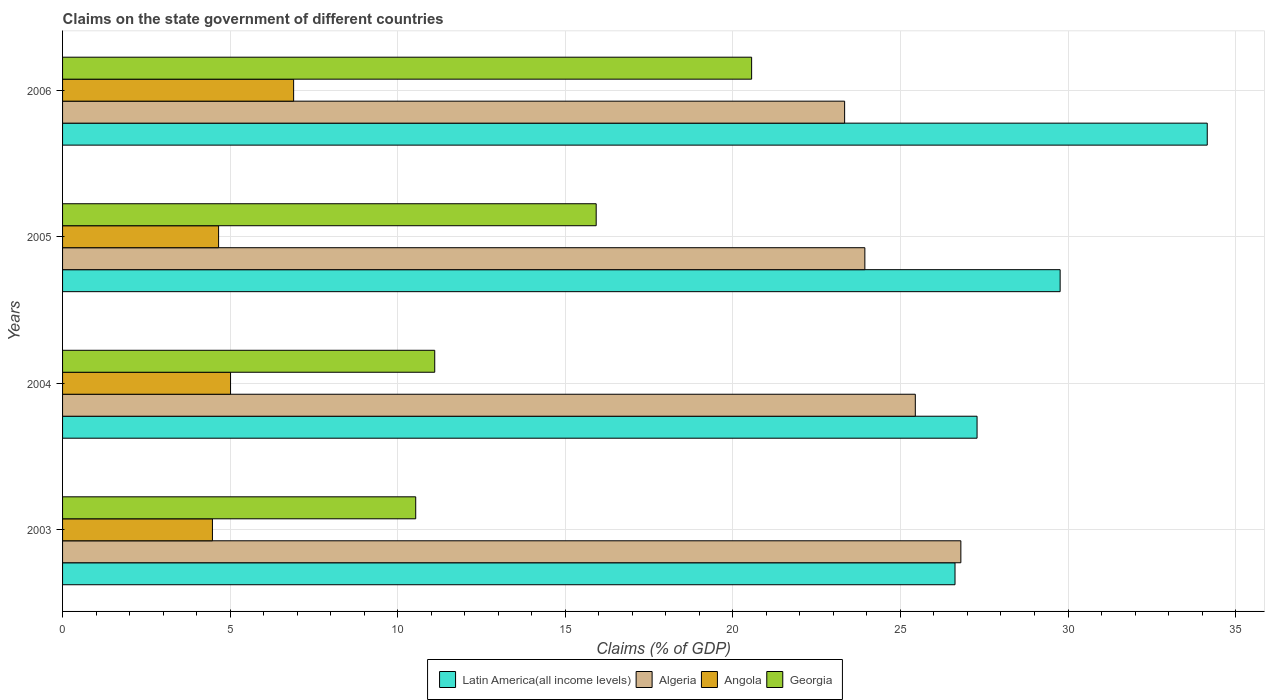In how many cases, is the number of bars for a given year not equal to the number of legend labels?
Offer a terse response. 0. What is the percentage of GDP claimed on the state government in Algeria in 2005?
Your answer should be compact. 23.94. Across all years, what is the maximum percentage of GDP claimed on the state government in Latin America(all income levels)?
Your response must be concise. 34.15. Across all years, what is the minimum percentage of GDP claimed on the state government in Georgia?
Offer a terse response. 10.54. In which year was the percentage of GDP claimed on the state government in Angola maximum?
Provide a short and direct response. 2006. What is the total percentage of GDP claimed on the state government in Latin America(all income levels) in the graph?
Ensure brevity in your answer.  117.83. What is the difference between the percentage of GDP claimed on the state government in Angola in 2003 and that in 2004?
Your answer should be very brief. -0.54. What is the difference between the percentage of GDP claimed on the state government in Latin America(all income levels) in 2004 and the percentage of GDP claimed on the state government in Georgia in 2003?
Provide a short and direct response. 16.75. What is the average percentage of GDP claimed on the state government in Angola per year?
Your answer should be very brief. 5.26. In the year 2005, what is the difference between the percentage of GDP claimed on the state government in Algeria and percentage of GDP claimed on the state government in Georgia?
Provide a short and direct response. 8.02. What is the ratio of the percentage of GDP claimed on the state government in Angola in 2004 to that in 2005?
Your answer should be very brief. 1.08. Is the difference between the percentage of GDP claimed on the state government in Algeria in 2003 and 2004 greater than the difference between the percentage of GDP claimed on the state government in Georgia in 2003 and 2004?
Keep it short and to the point. Yes. What is the difference between the highest and the second highest percentage of GDP claimed on the state government in Georgia?
Ensure brevity in your answer.  4.64. What is the difference between the highest and the lowest percentage of GDP claimed on the state government in Algeria?
Provide a succinct answer. 3.47. Is the sum of the percentage of GDP claimed on the state government in Georgia in 2003 and 2005 greater than the maximum percentage of GDP claimed on the state government in Angola across all years?
Keep it short and to the point. Yes. Is it the case that in every year, the sum of the percentage of GDP claimed on the state government in Latin America(all income levels) and percentage of GDP claimed on the state government in Georgia is greater than the sum of percentage of GDP claimed on the state government in Algeria and percentage of GDP claimed on the state government in Angola?
Your answer should be very brief. Yes. What does the 3rd bar from the top in 2004 represents?
Keep it short and to the point. Algeria. What does the 1st bar from the bottom in 2006 represents?
Offer a very short reply. Latin America(all income levels). Is it the case that in every year, the sum of the percentage of GDP claimed on the state government in Latin America(all income levels) and percentage of GDP claimed on the state government in Algeria is greater than the percentage of GDP claimed on the state government in Angola?
Your response must be concise. Yes. How many bars are there?
Offer a terse response. 16. Are all the bars in the graph horizontal?
Your answer should be compact. Yes. How many years are there in the graph?
Ensure brevity in your answer.  4. Are the values on the major ticks of X-axis written in scientific E-notation?
Provide a short and direct response. No. Does the graph contain any zero values?
Provide a short and direct response. No. Where does the legend appear in the graph?
Provide a succinct answer. Bottom center. How are the legend labels stacked?
Ensure brevity in your answer.  Horizontal. What is the title of the graph?
Provide a short and direct response. Claims on the state government of different countries. Does "Vanuatu" appear as one of the legend labels in the graph?
Your answer should be compact. No. What is the label or title of the X-axis?
Offer a terse response. Claims (% of GDP). What is the Claims (% of GDP) of Latin America(all income levels) in 2003?
Give a very brief answer. 26.63. What is the Claims (% of GDP) in Algeria in 2003?
Provide a short and direct response. 26.8. What is the Claims (% of GDP) in Angola in 2003?
Keep it short and to the point. 4.47. What is the Claims (% of GDP) in Georgia in 2003?
Keep it short and to the point. 10.54. What is the Claims (% of GDP) in Latin America(all income levels) in 2004?
Your answer should be compact. 27.29. What is the Claims (% of GDP) in Algeria in 2004?
Your answer should be very brief. 25.44. What is the Claims (% of GDP) of Angola in 2004?
Offer a terse response. 5.01. What is the Claims (% of GDP) in Georgia in 2004?
Make the answer very short. 11.1. What is the Claims (% of GDP) of Latin America(all income levels) in 2005?
Offer a terse response. 29.76. What is the Claims (% of GDP) of Algeria in 2005?
Keep it short and to the point. 23.94. What is the Claims (% of GDP) of Angola in 2005?
Keep it short and to the point. 4.66. What is the Claims (% of GDP) in Georgia in 2005?
Your answer should be compact. 15.92. What is the Claims (% of GDP) in Latin America(all income levels) in 2006?
Your response must be concise. 34.15. What is the Claims (% of GDP) of Algeria in 2006?
Your answer should be very brief. 23.33. What is the Claims (% of GDP) in Angola in 2006?
Provide a short and direct response. 6.89. What is the Claims (% of GDP) of Georgia in 2006?
Offer a very short reply. 20.56. Across all years, what is the maximum Claims (% of GDP) of Latin America(all income levels)?
Your response must be concise. 34.15. Across all years, what is the maximum Claims (% of GDP) of Algeria?
Make the answer very short. 26.8. Across all years, what is the maximum Claims (% of GDP) in Angola?
Make the answer very short. 6.89. Across all years, what is the maximum Claims (% of GDP) of Georgia?
Your answer should be very brief. 20.56. Across all years, what is the minimum Claims (% of GDP) in Latin America(all income levels)?
Provide a short and direct response. 26.63. Across all years, what is the minimum Claims (% of GDP) in Algeria?
Offer a terse response. 23.33. Across all years, what is the minimum Claims (% of GDP) in Angola?
Provide a succinct answer. 4.47. Across all years, what is the minimum Claims (% of GDP) in Georgia?
Ensure brevity in your answer.  10.54. What is the total Claims (% of GDP) of Latin America(all income levels) in the graph?
Offer a very short reply. 117.83. What is the total Claims (% of GDP) of Algeria in the graph?
Keep it short and to the point. 99.52. What is the total Claims (% of GDP) in Angola in the graph?
Your answer should be compact. 21.03. What is the total Claims (% of GDP) of Georgia in the graph?
Ensure brevity in your answer.  58.12. What is the difference between the Claims (% of GDP) in Latin America(all income levels) in 2003 and that in 2004?
Offer a very short reply. -0.66. What is the difference between the Claims (% of GDP) in Algeria in 2003 and that in 2004?
Keep it short and to the point. 1.36. What is the difference between the Claims (% of GDP) of Angola in 2003 and that in 2004?
Your answer should be compact. -0.54. What is the difference between the Claims (% of GDP) of Georgia in 2003 and that in 2004?
Make the answer very short. -0.57. What is the difference between the Claims (% of GDP) in Latin America(all income levels) in 2003 and that in 2005?
Give a very brief answer. -3.14. What is the difference between the Claims (% of GDP) in Algeria in 2003 and that in 2005?
Keep it short and to the point. 2.86. What is the difference between the Claims (% of GDP) in Angola in 2003 and that in 2005?
Make the answer very short. -0.18. What is the difference between the Claims (% of GDP) in Georgia in 2003 and that in 2005?
Ensure brevity in your answer.  -5.38. What is the difference between the Claims (% of GDP) of Latin America(all income levels) in 2003 and that in 2006?
Make the answer very short. -7.53. What is the difference between the Claims (% of GDP) in Algeria in 2003 and that in 2006?
Ensure brevity in your answer.  3.47. What is the difference between the Claims (% of GDP) of Angola in 2003 and that in 2006?
Your response must be concise. -2.42. What is the difference between the Claims (% of GDP) of Georgia in 2003 and that in 2006?
Provide a succinct answer. -10.02. What is the difference between the Claims (% of GDP) of Latin America(all income levels) in 2004 and that in 2005?
Your answer should be very brief. -2.48. What is the difference between the Claims (% of GDP) in Algeria in 2004 and that in 2005?
Give a very brief answer. 1.51. What is the difference between the Claims (% of GDP) of Angola in 2004 and that in 2005?
Offer a terse response. 0.36. What is the difference between the Claims (% of GDP) of Georgia in 2004 and that in 2005?
Your answer should be very brief. -4.82. What is the difference between the Claims (% of GDP) of Latin America(all income levels) in 2004 and that in 2006?
Offer a terse response. -6.87. What is the difference between the Claims (% of GDP) in Algeria in 2004 and that in 2006?
Keep it short and to the point. 2.11. What is the difference between the Claims (% of GDP) in Angola in 2004 and that in 2006?
Offer a terse response. -1.88. What is the difference between the Claims (% of GDP) in Georgia in 2004 and that in 2006?
Offer a very short reply. -9.46. What is the difference between the Claims (% of GDP) in Latin America(all income levels) in 2005 and that in 2006?
Ensure brevity in your answer.  -4.39. What is the difference between the Claims (% of GDP) in Algeria in 2005 and that in 2006?
Keep it short and to the point. 0.6. What is the difference between the Claims (% of GDP) of Angola in 2005 and that in 2006?
Offer a very short reply. -2.24. What is the difference between the Claims (% of GDP) in Georgia in 2005 and that in 2006?
Provide a short and direct response. -4.64. What is the difference between the Claims (% of GDP) of Latin America(all income levels) in 2003 and the Claims (% of GDP) of Algeria in 2004?
Offer a very short reply. 1.18. What is the difference between the Claims (% of GDP) in Latin America(all income levels) in 2003 and the Claims (% of GDP) in Angola in 2004?
Ensure brevity in your answer.  21.62. What is the difference between the Claims (% of GDP) of Latin America(all income levels) in 2003 and the Claims (% of GDP) of Georgia in 2004?
Offer a terse response. 15.52. What is the difference between the Claims (% of GDP) of Algeria in 2003 and the Claims (% of GDP) of Angola in 2004?
Provide a succinct answer. 21.79. What is the difference between the Claims (% of GDP) in Algeria in 2003 and the Claims (% of GDP) in Georgia in 2004?
Offer a very short reply. 15.7. What is the difference between the Claims (% of GDP) of Angola in 2003 and the Claims (% of GDP) of Georgia in 2004?
Give a very brief answer. -6.63. What is the difference between the Claims (% of GDP) of Latin America(all income levels) in 2003 and the Claims (% of GDP) of Algeria in 2005?
Your response must be concise. 2.69. What is the difference between the Claims (% of GDP) in Latin America(all income levels) in 2003 and the Claims (% of GDP) in Angola in 2005?
Give a very brief answer. 21.97. What is the difference between the Claims (% of GDP) of Latin America(all income levels) in 2003 and the Claims (% of GDP) of Georgia in 2005?
Provide a succinct answer. 10.71. What is the difference between the Claims (% of GDP) of Algeria in 2003 and the Claims (% of GDP) of Angola in 2005?
Your answer should be very brief. 22.15. What is the difference between the Claims (% of GDP) of Algeria in 2003 and the Claims (% of GDP) of Georgia in 2005?
Offer a terse response. 10.88. What is the difference between the Claims (% of GDP) in Angola in 2003 and the Claims (% of GDP) in Georgia in 2005?
Keep it short and to the point. -11.45. What is the difference between the Claims (% of GDP) of Latin America(all income levels) in 2003 and the Claims (% of GDP) of Algeria in 2006?
Your answer should be compact. 3.29. What is the difference between the Claims (% of GDP) in Latin America(all income levels) in 2003 and the Claims (% of GDP) in Angola in 2006?
Offer a terse response. 19.73. What is the difference between the Claims (% of GDP) in Latin America(all income levels) in 2003 and the Claims (% of GDP) in Georgia in 2006?
Offer a terse response. 6.07. What is the difference between the Claims (% of GDP) of Algeria in 2003 and the Claims (% of GDP) of Angola in 2006?
Your answer should be very brief. 19.91. What is the difference between the Claims (% of GDP) of Algeria in 2003 and the Claims (% of GDP) of Georgia in 2006?
Offer a terse response. 6.24. What is the difference between the Claims (% of GDP) of Angola in 2003 and the Claims (% of GDP) of Georgia in 2006?
Offer a very short reply. -16.09. What is the difference between the Claims (% of GDP) in Latin America(all income levels) in 2004 and the Claims (% of GDP) in Algeria in 2005?
Provide a succinct answer. 3.35. What is the difference between the Claims (% of GDP) in Latin America(all income levels) in 2004 and the Claims (% of GDP) in Angola in 2005?
Your answer should be compact. 22.63. What is the difference between the Claims (% of GDP) of Latin America(all income levels) in 2004 and the Claims (% of GDP) of Georgia in 2005?
Your answer should be compact. 11.36. What is the difference between the Claims (% of GDP) of Algeria in 2004 and the Claims (% of GDP) of Angola in 2005?
Provide a short and direct response. 20.79. What is the difference between the Claims (% of GDP) in Algeria in 2004 and the Claims (% of GDP) in Georgia in 2005?
Ensure brevity in your answer.  9.52. What is the difference between the Claims (% of GDP) in Angola in 2004 and the Claims (% of GDP) in Georgia in 2005?
Your response must be concise. -10.91. What is the difference between the Claims (% of GDP) of Latin America(all income levels) in 2004 and the Claims (% of GDP) of Algeria in 2006?
Offer a very short reply. 3.95. What is the difference between the Claims (% of GDP) of Latin America(all income levels) in 2004 and the Claims (% of GDP) of Angola in 2006?
Make the answer very short. 20.39. What is the difference between the Claims (% of GDP) of Latin America(all income levels) in 2004 and the Claims (% of GDP) of Georgia in 2006?
Ensure brevity in your answer.  6.73. What is the difference between the Claims (% of GDP) of Algeria in 2004 and the Claims (% of GDP) of Angola in 2006?
Give a very brief answer. 18.55. What is the difference between the Claims (% of GDP) of Algeria in 2004 and the Claims (% of GDP) of Georgia in 2006?
Offer a very short reply. 4.88. What is the difference between the Claims (% of GDP) in Angola in 2004 and the Claims (% of GDP) in Georgia in 2006?
Make the answer very short. -15.55. What is the difference between the Claims (% of GDP) in Latin America(all income levels) in 2005 and the Claims (% of GDP) in Algeria in 2006?
Your answer should be very brief. 6.43. What is the difference between the Claims (% of GDP) in Latin America(all income levels) in 2005 and the Claims (% of GDP) in Angola in 2006?
Offer a very short reply. 22.87. What is the difference between the Claims (% of GDP) in Latin America(all income levels) in 2005 and the Claims (% of GDP) in Georgia in 2006?
Offer a terse response. 9.21. What is the difference between the Claims (% of GDP) in Algeria in 2005 and the Claims (% of GDP) in Angola in 2006?
Ensure brevity in your answer.  17.04. What is the difference between the Claims (% of GDP) in Algeria in 2005 and the Claims (% of GDP) in Georgia in 2006?
Your answer should be very brief. 3.38. What is the difference between the Claims (% of GDP) of Angola in 2005 and the Claims (% of GDP) of Georgia in 2006?
Ensure brevity in your answer.  -15.9. What is the average Claims (% of GDP) in Latin America(all income levels) per year?
Your answer should be very brief. 29.46. What is the average Claims (% of GDP) in Algeria per year?
Your response must be concise. 24.88. What is the average Claims (% of GDP) of Angola per year?
Keep it short and to the point. 5.26. What is the average Claims (% of GDP) of Georgia per year?
Ensure brevity in your answer.  14.53. In the year 2003, what is the difference between the Claims (% of GDP) of Latin America(all income levels) and Claims (% of GDP) of Algeria?
Give a very brief answer. -0.17. In the year 2003, what is the difference between the Claims (% of GDP) of Latin America(all income levels) and Claims (% of GDP) of Angola?
Provide a short and direct response. 22.16. In the year 2003, what is the difference between the Claims (% of GDP) in Latin America(all income levels) and Claims (% of GDP) in Georgia?
Make the answer very short. 16.09. In the year 2003, what is the difference between the Claims (% of GDP) of Algeria and Claims (% of GDP) of Angola?
Keep it short and to the point. 22.33. In the year 2003, what is the difference between the Claims (% of GDP) in Algeria and Claims (% of GDP) in Georgia?
Ensure brevity in your answer.  16.27. In the year 2003, what is the difference between the Claims (% of GDP) in Angola and Claims (% of GDP) in Georgia?
Ensure brevity in your answer.  -6.07. In the year 2004, what is the difference between the Claims (% of GDP) in Latin America(all income levels) and Claims (% of GDP) in Algeria?
Your answer should be compact. 1.84. In the year 2004, what is the difference between the Claims (% of GDP) of Latin America(all income levels) and Claims (% of GDP) of Angola?
Ensure brevity in your answer.  22.27. In the year 2004, what is the difference between the Claims (% of GDP) in Latin America(all income levels) and Claims (% of GDP) in Georgia?
Offer a terse response. 16.18. In the year 2004, what is the difference between the Claims (% of GDP) in Algeria and Claims (% of GDP) in Angola?
Offer a terse response. 20.43. In the year 2004, what is the difference between the Claims (% of GDP) of Algeria and Claims (% of GDP) of Georgia?
Provide a succinct answer. 14.34. In the year 2004, what is the difference between the Claims (% of GDP) of Angola and Claims (% of GDP) of Georgia?
Your answer should be very brief. -6.09. In the year 2005, what is the difference between the Claims (% of GDP) of Latin America(all income levels) and Claims (% of GDP) of Algeria?
Your answer should be very brief. 5.83. In the year 2005, what is the difference between the Claims (% of GDP) in Latin America(all income levels) and Claims (% of GDP) in Angola?
Keep it short and to the point. 25.11. In the year 2005, what is the difference between the Claims (% of GDP) of Latin America(all income levels) and Claims (% of GDP) of Georgia?
Give a very brief answer. 13.84. In the year 2005, what is the difference between the Claims (% of GDP) of Algeria and Claims (% of GDP) of Angola?
Provide a short and direct response. 19.28. In the year 2005, what is the difference between the Claims (% of GDP) in Algeria and Claims (% of GDP) in Georgia?
Provide a short and direct response. 8.02. In the year 2005, what is the difference between the Claims (% of GDP) of Angola and Claims (% of GDP) of Georgia?
Your answer should be compact. -11.27. In the year 2006, what is the difference between the Claims (% of GDP) in Latin America(all income levels) and Claims (% of GDP) in Algeria?
Keep it short and to the point. 10.82. In the year 2006, what is the difference between the Claims (% of GDP) in Latin America(all income levels) and Claims (% of GDP) in Angola?
Offer a terse response. 27.26. In the year 2006, what is the difference between the Claims (% of GDP) in Latin America(all income levels) and Claims (% of GDP) in Georgia?
Offer a very short reply. 13.6. In the year 2006, what is the difference between the Claims (% of GDP) in Algeria and Claims (% of GDP) in Angola?
Your answer should be compact. 16.44. In the year 2006, what is the difference between the Claims (% of GDP) in Algeria and Claims (% of GDP) in Georgia?
Provide a short and direct response. 2.77. In the year 2006, what is the difference between the Claims (% of GDP) in Angola and Claims (% of GDP) in Georgia?
Your answer should be compact. -13.67. What is the ratio of the Claims (% of GDP) in Latin America(all income levels) in 2003 to that in 2004?
Provide a short and direct response. 0.98. What is the ratio of the Claims (% of GDP) in Algeria in 2003 to that in 2004?
Provide a succinct answer. 1.05. What is the ratio of the Claims (% of GDP) in Angola in 2003 to that in 2004?
Give a very brief answer. 0.89. What is the ratio of the Claims (% of GDP) of Georgia in 2003 to that in 2004?
Give a very brief answer. 0.95. What is the ratio of the Claims (% of GDP) in Latin America(all income levels) in 2003 to that in 2005?
Keep it short and to the point. 0.89. What is the ratio of the Claims (% of GDP) of Algeria in 2003 to that in 2005?
Ensure brevity in your answer.  1.12. What is the ratio of the Claims (% of GDP) in Angola in 2003 to that in 2005?
Make the answer very short. 0.96. What is the ratio of the Claims (% of GDP) of Georgia in 2003 to that in 2005?
Offer a very short reply. 0.66. What is the ratio of the Claims (% of GDP) in Latin America(all income levels) in 2003 to that in 2006?
Ensure brevity in your answer.  0.78. What is the ratio of the Claims (% of GDP) of Algeria in 2003 to that in 2006?
Offer a very short reply. 1.15. What is the ratio of the Claims (% of GDP) of Angola in 2003 to that in 2006?
Offer a very short reply. 0.65. What is the ratio of the Claims (% of GDP) of Georgia in 2003 to that in 2006?
Give a very brief answer. 0.51. What is the ratio of the Claims (% of GDP) in Algeria in 2004 to that in 2005?
Offer a terse response. 1.06. What is the ratio of the Claims (% of GDP) of Angola in 2004 to that in 2005?
Make the answer very short. 1.08. What is the ratio of the Claims (% of GDP) of Georgia in 2004 to that in 2005?
Your answer should be compact. 0.7. What is the ratio of the Claims (% of GDP) of Latin America(all income levels) in 2004 to that in 2006?
Give a very brief answer. 0.8. What is the ratio of the Claims (% of GDP) of Algeria in 2004 to that in 2006?
Offer a very short reply. 1.09. What is the ratio of the Claims (% of GDP) of Angola in 2004 to that in 2006?
Keep it short and to the point. 0.73. What is the ratio of the Claims (% of GDP) of Georgia in 2004 to that in 2006?
Offer a very short reply. 0.54. What is the ratio of the Claims (% of GDP) of Latin America(all income levels) in 2005 to that in 2006?
Ensure brevity in your answer.  0.87. What is the ratio of the Claims (% of GDP) of Algeria in 2005 to that in 2006?
Ensure brevity in your answer.  1.03. What is the ratio of the Claims (% of GDP) of Angola in 2005 to that in 2006?
Your answer should be very brief. 0.68. What is the ratio of the Claims (% of GDP) in Georgia in 2005 to that in 2006?
Provide a succinct answer. 0.77. What is the difference between the highest and the second highest Claims (% of GDP) in Latin America(all income levels)?
Your answer should be very brief. 4.39. What is the difference between the highest and the second highest Claims (% of GDP) in Algeria?
Your answer should be compact. 1.36. What is the difference between the highest and the second highest Claims (% of GDP) of Angola?
Your answer should be very brief. 1.88. What is the difference between the highest and the second highest Claims (% of GDP) in Georgia?
Offer a terse response. 4.64. What is the difference between the highest and the lowest Claims (% of GDP) in Latin America(all income levels)?
Provide a succinct answer. 7.53. What is the difference between the highest and the lowest Claims (% of GDP) of Algeria?
Keep it short and to the point. 3.47. What is the difference between the highest and the lowest Claims (% of GDP) of Angola?
Provide a succinct answer. 2.42. What is the difference between the highest and the lowest Claims (% of GDP) of Georgia?
Your answer should be very brief. 10.02. 